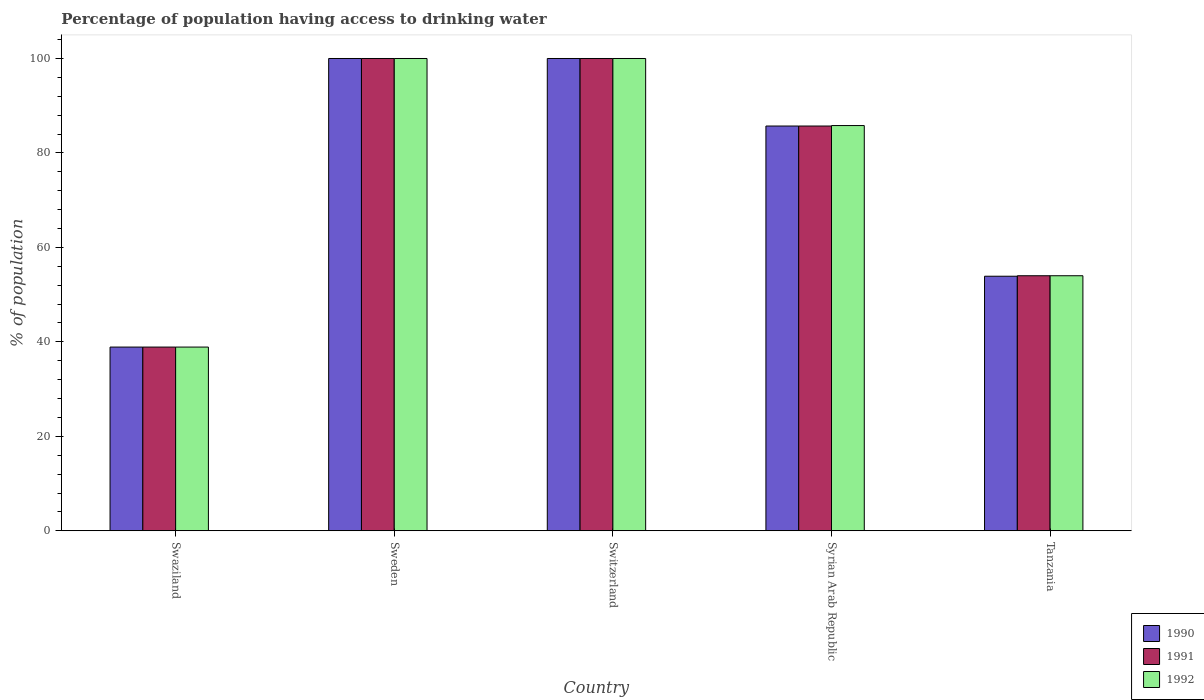How many different coloured bars are there?
Keep it short and to the point. 3. Are the number of bars on each tick of the X-axis equal?
Give a very brief answer. Yes. What is the label of the 3rd group of bars from the left?
Offer a terse response. Switzerland. What is the percentage of population having access to drinking water in 1991 in Switzerland?
Make the answer very short. 100. Across all countries, what is the maximum percentage of population having access to drinking water in 1991?
Provide a short and direct response. 100. Across all countries, what is the minimum percentage of population having access to drinking water in 1991?
Keep it short and to the point. 38.9. In which country was the percentage of population having access to drinking water in 1992 minimum?
Provide a succinct answer. Swaziland. What is the total percentage of population having access to drinking water in 1992 in the graph?
Provide a succinct answer. 378.7. What is the average percentage of population having access to drinking water in 1990 per country?
Your answer should be compact. 75.7. What is the difference between the percentage of population having access to drinking water of/in 1992 and percentage of population having access to drinking water of/in 1990 in Tanzania?
Ensure brevity in your answer.  0.1. In how many countries, is the percentage of population having access to drinking water in 1991 greater than 96 %?
Offer a terse response. 2. What is the ratio of the percentage of population having access to drinking water in 1990 in Sweden to that in Tanzania?
Provide a short and direct response. 1.86. Is the difference between the percentage of population having access to drinking water in 1992 in Sweden and Tanzania greater than the difference between the percentage of population having access to drinking water in 1990 in Sweden and Tanzania?
Provide a short and direct response. No. What is the difference between the highest and the second highest percentage of population having access to drinking water in 1992?
Provide a succinct answer. 14.2. What is the difference between the highest and the lowest percentage of population having access to drinking water in 1991?
Your answer should be very brief. 61.1. In how many countries, is the percentage of population having access to drinking water in 1992 greater than the average percentage of population having access to drinking water in 1992 taken over all countries?
Your response must be concise. 3. Is the sum of the percentage of population having access to drinking water in 1992 in Swaziland and Switzerland greater than the maximum percentage of population having access to drinking water in 1990 across all countries?
Keep it short and to the point. Yes. What does the 1st bar from the left in Sweden represents?
Ensure brevity in your answer.  1990. How many bars are there?
Make the answer very short. 15. How many countries are there in the graph?
Your response must be concise. 5. What is the difference between two consecutive major ticks on the Y-axis?
Your answer should be very brief. 20. Does the graph contain grids?
Ensure brevity in your answer.  No. How many legend labels are there?
Give a very brief answer. 3. What is the title of the graph?
Offer a very short reply. Percentage of population having access to drinking water. What is the label or title of the Y-axis?
Provide a short and direct response. % of population. What is the % of population in 1990 in Swaziland?
Give a very brief answer. 38.9. What is the % of population in 1991 in Swaziland?
Ensure brevity in your answer.  38.9. What is the % of population in 1992 in Swaziland?
Your answer should be compact. 38.9. What is the % of population of 1991 in Sweden?
Provide a succinct answer. 100. What is the % of population in 1992 in Sweden?
Your answer should be compact. 100. What is the % of population of 1990 in Syrian Arab Republic?
Provide a succinct answer. 85.7. What is the % of population of 1991 in Syrian Arab Republic?
Provide a short and direct response. 85.7. What is the % of population of 1992 in Syrian Arab Republic?
Your answer should be compact. 85.8. What is the % of population in 1990 in Tanzania?
Provide a succinct answer. 53.9. What is the % of population in 1992 in Tanzania?
Give a very brief answer. 54. Across all countries, what is the maximum % of population of 1990?
Your answer should be very brief. 100. Across all countries, what is the maximum % of population of 1991?
Give a very brief answer. 100. Across all countries, what is the maximum % of population of 1992?
Provide a succinct answer. 100. Across all countries, what is the minimum % of population of 1990?
Your response must be concise. 38.9. Across all countries, what is the minimum % of population in 1991?
Provide a succinct answer. 38.9. Across all countries, what is the minimum % of population of 1992?
Provide a succinct answer. 38.9. What is the total % of population in 1990 in the graph?
Give a very brief answer. 378.5. What is the total % of population in 1991 in the graph?
Offer a terse response. 378.6. What is the total % of population of 1992 in the graph?
Offer a terse response. 378.7. What is the difference between the % of population in 1990 in Swaziland and that in Sweden?
Give a very brief answer. -61.1. What is the difference between the % of population of 1991 in Swaziland and that in Sweden?
Offer a very short reply. -61.1. What is the difference between the % of population of 1992 in Swaziland and that in Sweden?
Provide a short and direct response. -61.1. What is the difference between the % of population of 1990 in Swaziland and that in Switzerland?
Provide a succinct answer. -61.1. What is the difference between the % of population of 1991 in Swaziland and that in Switzerland?
Provide a short and direct response. -61.1. What is the difference between the % of population in 1992 in Swaziland and that in Switzerland?
Keep it short and to the point. -61.1. What is the difference between the % of population in 1990 in Swaziland and that in Syrian Arab Republic?
Ensure brevity in your answer.  -46.8. What is the difference between the % of population in 1991 in Swaziland and that in Syrian Arab Republic?
Keep it short and to the point. -46.8. What is the difference between the % of population in 1992 in Swaziland and that in Syrian Arab Republic?
Give a very brief answer. -46.9. What is the difference between the % of population in 1990 in Swaziland and that in Tanzania?
Your answer should be compact. -15. What is the difference between the % of population in 1991 in Swaziland and that in Tanzania?
Offer a very short reply. -15.1. What is the difference between the % of population of 1992 in Swaziland and that in Tanzania?
Ensure brevity in your answer.  -15.1. What is the difference between the % of population of 1990 in Sweden and that in Switzerland?
Your response must be concise. 0. What is the difference between the % of population of 1991 in Sweden and that in Switzerland?
Ensure brevity in your answer.  0. What is the difference between the % of population in 1992 in Sweden and that in Switzerland?
Your answer should be compact. 0. What is the difference between the % of population in 1990 in Sweden and that in Syrian Arab Republic?
Ensure brevity in your answer.  14.3. What is the difference between the % of population of 1991 in Sweden and that in Syrian Arab Republic?
Provide a short and direct response. 14.3. What is the difference between the % of population of 1990 in Sweden and that in Tanzania?
Your answer should be compact. 46.1. What is the difference between the % of population of 1990 in Switzerland and that in Syrian Arab Republic?
Provide a short and direct response. 14.3. What is the difference between the % of population of 1990 in Switzerland and that in Tanzania?
Offer a terse response. 46.1. What is the difference between the % of population of 1991 in Switzerland and that in Tanzania?
Offer a terse response. 46. What is the difference between the % of population of 1992 in Switzerland and that in Tanzania?
Your response must be concise. 46. What is the difference between the % of population of 1990 in Syrian Arab Republic and that in Tanzania?
Ensure brevity in your answer.  31.8. What is the difference between the % of population of 1991 in Syrian Arab Republic and that in Tanzania?
Provide a short and direct response. 31.7. What is the difference between the % of population of 1992 in Syrian Arab Republic and that in Tanzania?
Provide a succinct answer. 31.8. What is the difference between the % of population in 1990 in Swaziland and the % of population in 1991 in Sweden?
Offer a very short reply. -61.1. What is the difference between the % of population in 1990 in Swaziland and the % of population in 1992 in Sweden?
Offer a terse response. -61.1. What is the difference between the % of population of 1991 in Swaziland and the % of population of 1992 in Sweden?
Offer a terse response. -61.1. What is the difference between the % of population of 1990 in Swaziland and the % of population of 1991 in Switzerland?
Offer a very short reply. -61.1. What is the difference between the % of population in 1990 in Swaziland and the % of population in 1992 in Switzerland?
Ensure brevity in your answer.  -61.1. What is the difference between the % of population of 1991 in Swaziland and the % of population of 1992 in Switzerland?
Make the answer very short. -61.1. What is the difference between the % of population of 1990 in Swaziland and the % of population of 1991 in Syrian Arab Republic?
Provide a succinct answer. -46.8. What is the difference between the % of population in 1990 in Swaziland and the % of population in 1992 in Syrian Arab Republic?
Offer a terse response. -46.9. What is the difference between the % of population of 1991 in Swaziland and the % of population of 1992 in Syrian Arab Republic?
Provide a short and direct response. -46.9. What is the difference between the % of population of 1990 in Swaziland and the % of population of 1991 in Tanzania?
Offer a very short reply. -15.1. What is the difference between the % of population of 1990 in Swaziland and the % of population of 1992 in Tanzania?
Your response must be concise. -15.1. What is the difference between the % of population of 1991 in Swaziland and the % of population of 1992 in Tanzania?
Offer a terse response. -15.1. What is the difference between the % of population in 1990 in Sweden and the % of population in 1992 in Switzerland?
Make the answer very short. 0. What is the difference between the % of population of 1991 in Sweden and the % of population of 1992 in Switzerland?
Make the answer very short. 0. What is the difference between the % of population of 1990 in Sweden and the % of population of 1992 in Syrian Arab Republic?
Provide a short and direct response. 14.2. What is the difference between the % of population in 1990 in Sweden and the % of population in 1992 in Tanzania?
Your answer should be very brief. 46. What is the difference between the % of population in 1990 in Switzerland and the % of population in 1992 in Syrian Arab Republic?
Your answer should be very brief. 14.2. What is the difference between the % of population of 1990 in Switzerland and the % of population of 1992 in Tanzania?
Provide a short and direct response. 46. What is the difference between the % of population in 1991 in Switzerland and the % of population in 1992 in Tanzania?
Your answer should be very brief. 46. What is the difference between the % of population of 1990 in Syrian Arab Republic and the % of population of 1991 in Tanzania?
Your response must be concise. 31.7. What is the difference between the % of population in 1990 in Syrian Arab Republic and the % of population in 1992 in Tanzania?
Your answer should be very brief. 31.7. What is the difference between the % of population in 1991 in Syrian Arab Republic and the % of population in 1992 in Tanzania?
Make the answer very short. 31.7. What is the average % of population in 1990 per country?
Keep it short and to the point. 75.7. What is the average % of population in 1991 per country?
Your answer should be very brief. 75.72. What is the average % of population in 1992 per country?
Keep it short and to the point. 75.74. What is the difference between the % of population of 1990 and % of population of 1992 in Swaziland?
Your answer should be compact. 0. What is the difference between the % of population in 1991 and % of population in 1992 in Swaziland?
Your response must be concise. 0. What is the difference between the % of population of 1990 and % of population of 1991 in Switzerland?
Your response must be concise. 0. What is the difference between the % of population in 1990 and % of population in 1992 in Switzerland?
Provide a succinct answer. 0. What is the difference between the % of population in 1990 and % of population in 1991 in Syrian Arab Republic?
Your answer should be very brief. 0. What is the difference between the % of population in 1990 and % of population in 1992 in Syrian Arab Republic?
Keep it short and to the point. -0.1. What is the difference between the % of population of 1991 and % of population of 1992 in Syrian Arab Republic?
Provide a short and direct response. -0.1. What is the difference between the % of population of 1990 and % of population of 1992 in Tanzania?
Provide a short and direct response. -0.1. What is the ratio of the % of population of 1990 in Swaziland to that in Sweden?
Ensure brevity in your answer.  0.39. What is the ratio of the % of population in 1991 in Swaziland to that in Sweden?
Provide a succinct answer. 0.39. What is the ratio of the % of population of 1992 in Swaziland to that in Sweden?
Keep it short and to the point. 0.39. What is the ratio of the % of population of 1990 in Swaziland to that in Switzerland?
Make the answer very short. 0.39. What is the ratio of the % of population of 1991 in Swaziland to that in Switzerland?
Provide a short and direct response. 0.39. What is the ratio of the % of population of 1992 in Swaziland to that in Switzerland?
Offer a terse response. 0.39. What is the ratio of the % of population of 1990 in Swaziland to that in Syrian Arab Republic?
Your answer should be very brief. 0.45. What is the ratio of the % of population in 1991 in Swaziland to that in Syrian Arab Republic?
Make the answer very short. 0.45. What is the ratio of the % of population of 1992 in Swaziland to that in Syrian Arab Republic?
Your answer should be very brief. 0.45. What is the ratio of the % of population of 1990 in Swaziland to that in Tanzania?
Keep it short and to the point. 0.72. What is the ratio of the % of population in 1991 in Swaziland to that in Tanzania?
Your response must be concise. 0.72. What is the ratio of the % of population in 1992 in Swaziland to that in Tanzania?
Your answer should be compact. 0.72. What is the ratio of the % of population of 1992 in Sweden to that in Switzerland?
Give a very brief answer. 1. What is the ratio of the % of population of 1990 in Sweden to that in Syrian Arab Republic?
Provide a succinct answer. 1.17. What is the ratio of the % of population of 1991 in Sweden to that in Syrian Arab Republic?
Provide a succinct answer. 1.17. What is the ratio of the % of population in 1992 in Sweden to that in Syrian Arab Republic?
Offer a very short reply. 1.17. What is the ratio of the % of population in 1990 in Sweden to that in Tanzania?
Provide a short and direct response. 1.86. What is the ratio of the % of population in 1991 in Sweden to that in Tanzania?
Keep it short and to the point. 1.85. What is the ratio of the % of population in 1992 in Sweden to that in Tanzania?
Make the answer very short. 1.85. What is the ratio of the % of population in 1990 in Switzerland to that in Syrian Arab Republic?
Your answer should be very brief. 1.17. What is the ratio of the % of population of 1991 in Switzerland to that in Syrian Arab Republic?
Offer a terse response. 1.17. What is the ratio of the % of population in 1992 in Switzerland to that in Syrian Arab Republic?
Provide a short and direct response. 1.17. What is the ratio of the % of population in 1990 in Switzerland to that in Tanzania?
Keep it short and to the point. 1.86. What is the ratio of the % of population in 1991 in Switzerland to that in Tanzania?
Your answer should be very brief. 1.85. What is the ratio of the % of population of 1992 in Switzerland to that in Tanzania?
Give a very brief answer. 1.85. What is the ratio of the % of population in 1990 in Syrian Arab Republic to that in Tanzania?
Offer a terse response. 1.59. What is the ratio of the % of population in 1991 in Syrian Arab Republic to that in Tanzania?
Provide a succinct answer. 1.59. What is the ratio of the % of population in 1992 in Syrian Arab Republic to that in Tanzania?
Your response must be concise. 1.59. What is the difference between the highest and the second highest % of population in 1990?
Make the answer very short. 0. What is the difference between the highest and the second highest % of population in 1991?
Provide a short and direct response. 0. What is the difference between the highest and the lowest % of population in 1990?
Offer a terse response. 61.1. What is the difference between the highest and the lowest % of population in 1991?
Provide a succinct answer. 61.1. What is the difference between the highest and the lowest % of population of 1992?
Offer a terse response. 61.1. 